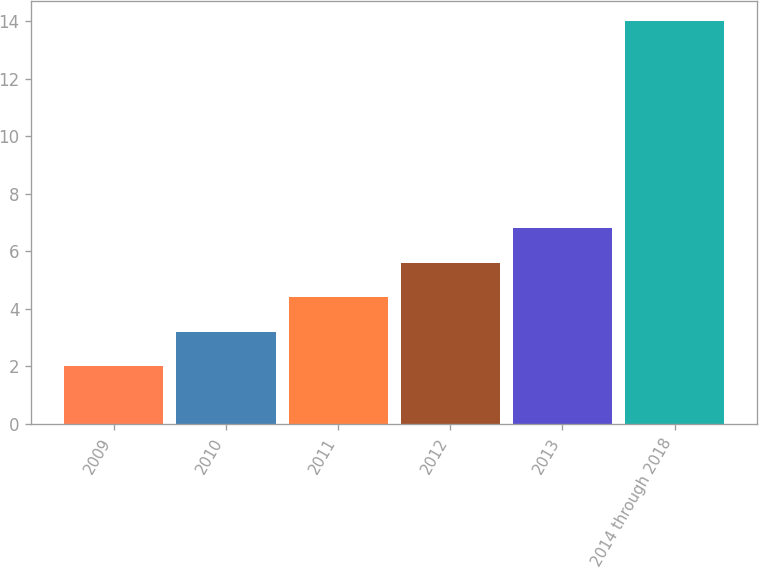<chart> <loc_0><loc_0><loc_500><loc_500><bar_chart><fcel>2009<fcel>2010<fcel>2011<fcel>2012<fcel>2013<fcel>2014 through 2018<nl><fcel>2<fcel>3.2<fcel>4.4<fcel>5.6<fcel>6.8<fcel>14<nl></chart> 